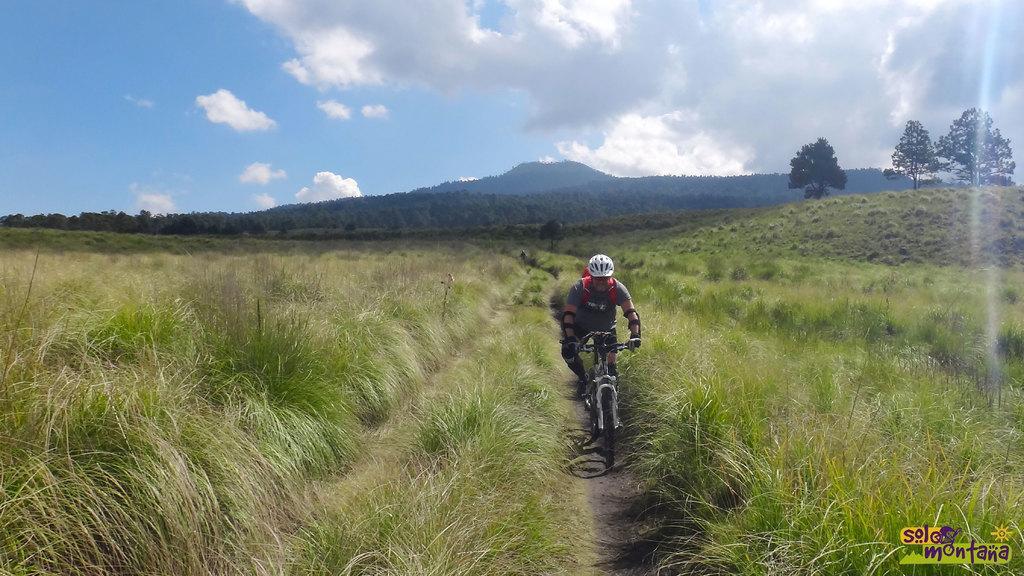Can you describe this image briefly? There is a person riding bicycle and there is green grass on either sides of him and there are trees and mountains in the background. 